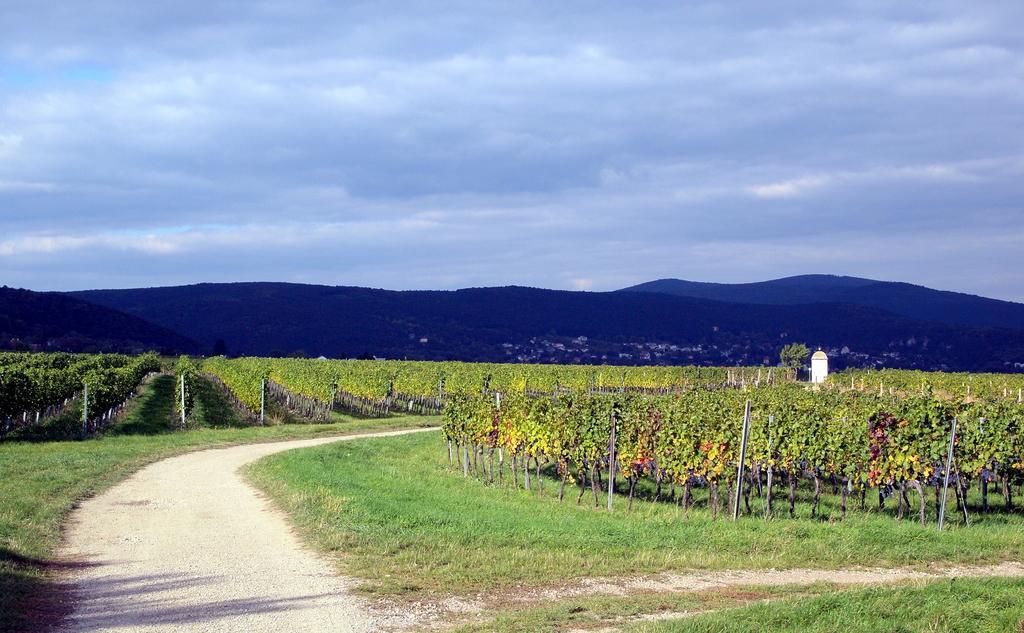Can you describe this image briefly? These are the plants, on the left side this is the way. At the top it's a sky. 